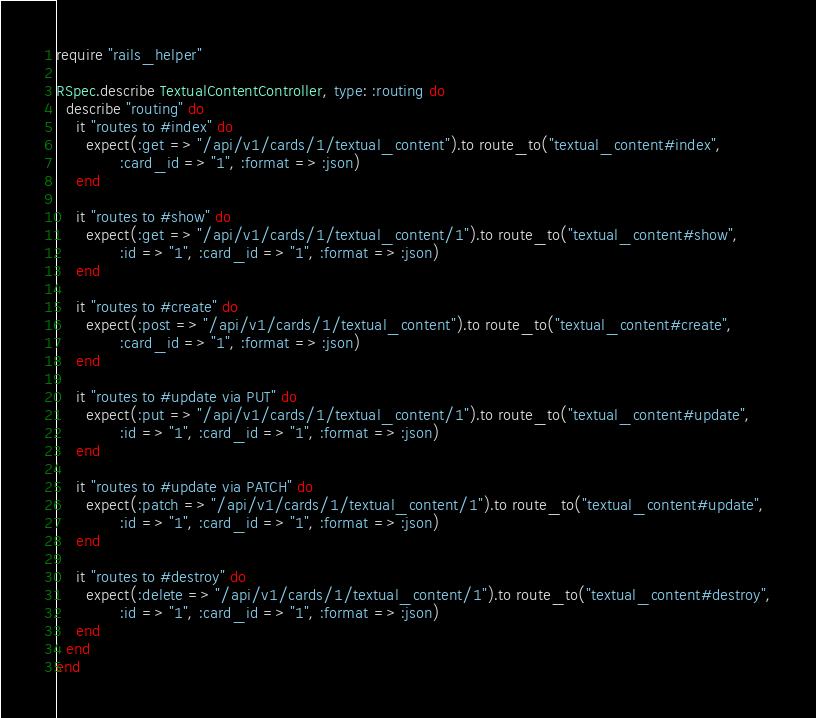Convert code to text. <code><loc_0><loc_0><loc_500><loc_500><_Ruby_>require "rails_helper"

RSpec.describe TextualContentController, type: :routing do
  describe "routing" do
    it "routes to #index" do
      expect(:get => "/api/v1/cards/1/textual_content").to route_to("textual_content#index",
             :card_id => "1", :format => :json)
    end

    it "routes to #show" do
      expect(:get => "/api/v1/cards/1/textual_content/1").to route_to("textual_content#show",
             :id => "1", :card_id => "1", :format => :json)
    end

    it "routes to #create" do
      expect(:post => "/api/v1/cards/1/textual_content").to route_to("textual_content#create",
             :card_id => "1", :format => :json)
    end

    it "routes to #update via PUT" do
      expect(:put => "/api/v1/cards/1/textual_content/1").to route_to("textual_content#update",
             :id => "1", :card_id => "1", :format => :json)
    end

    it "routes to #update via PATCH" do
      expect(:patch => "/api/v1/cards/1/textual_content/1").to route_to("textual_content#update",
             :id => "1", :card_id => "1", :format => :json)
    end

    it "routes to #destroy" do
      expect(:delete => "/api/v1/cards/1/textual_content/1").to route_to("textual_content#destroy",
             :id => "1", :card_id => "1", :format => :json)
    end
  end
end
</code> 